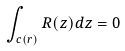<formula> <loc_0><loc_0><loc_500><loc_500>\int _ { c ( r ) } R ( z ) d z = 0</formula> 